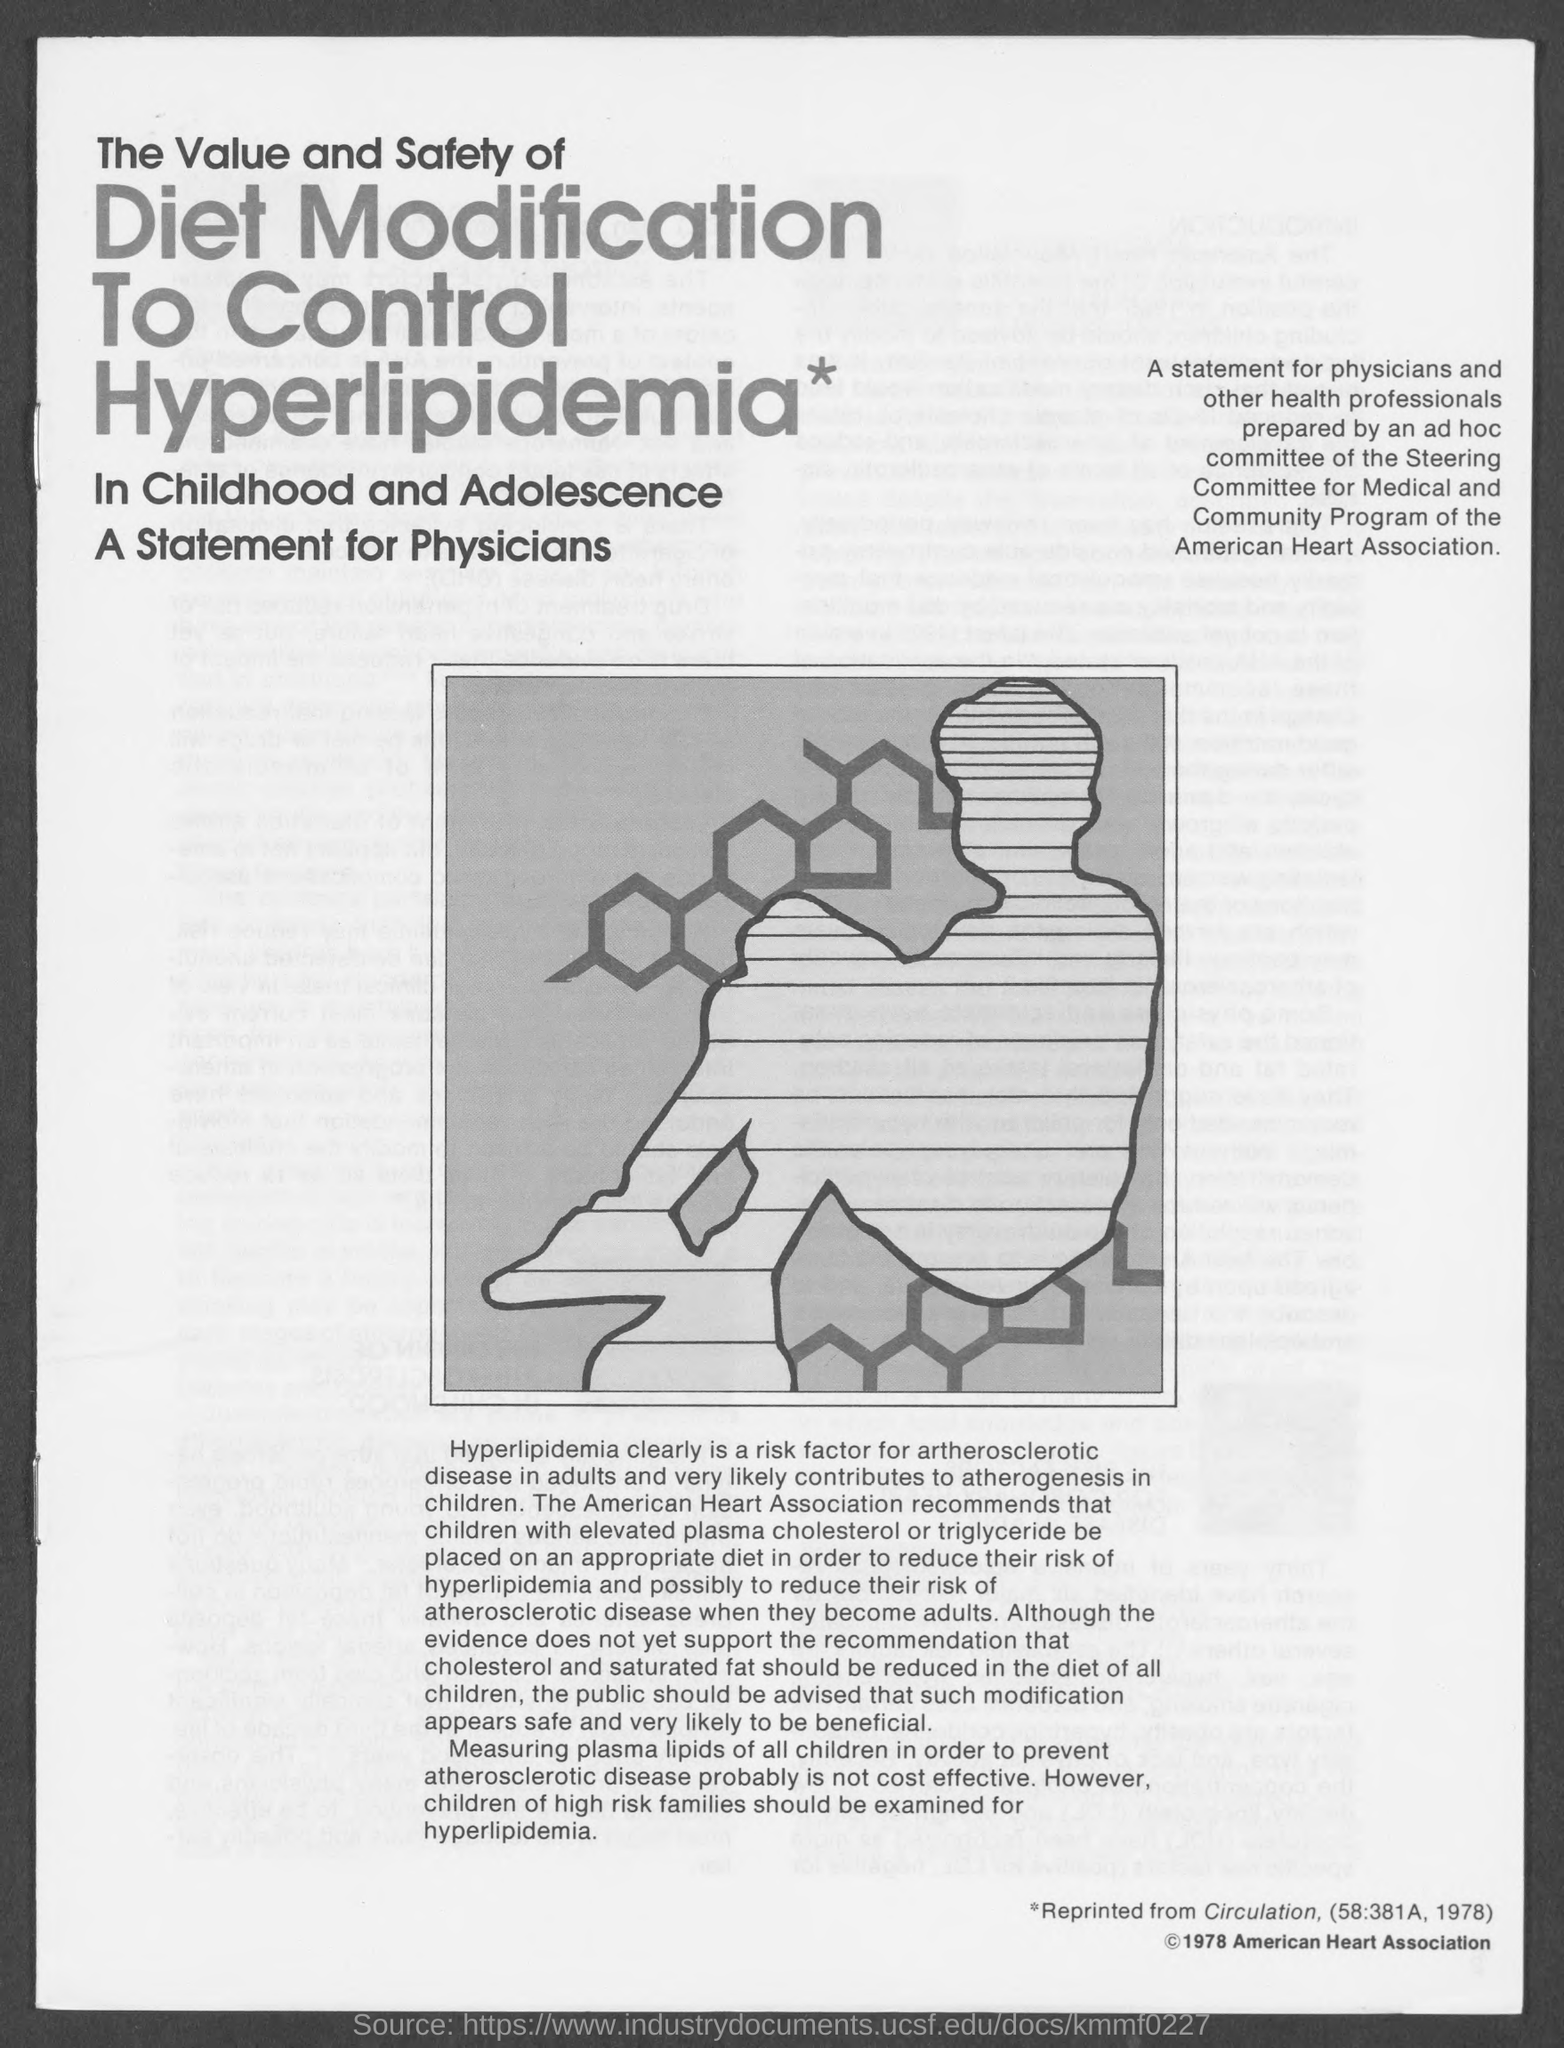Identify some key points in this picture. The American Heart Association is the name of a heart association. 